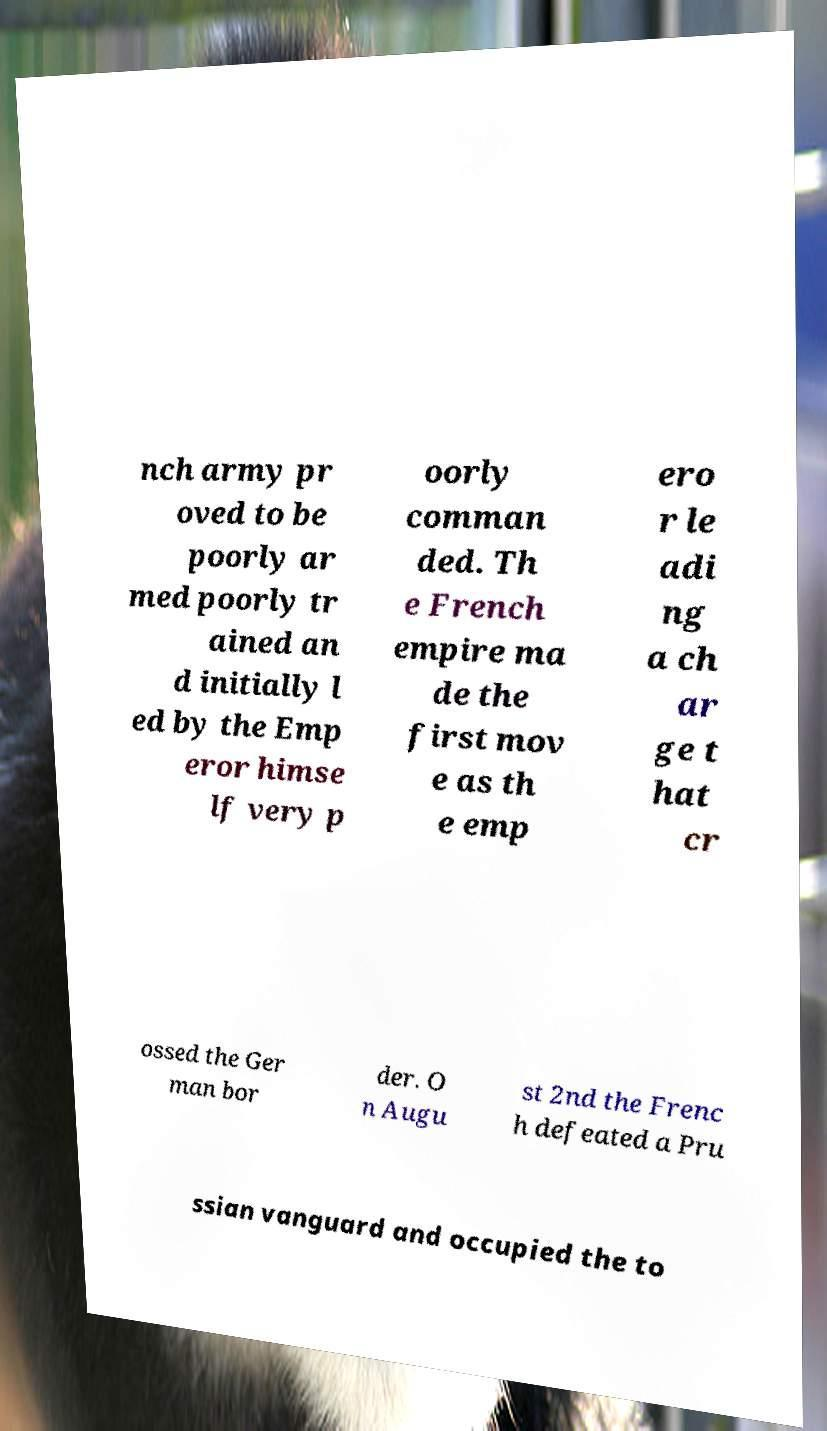I need the written content from this picture converted into text. Can you do that? nch army pr oved to be poorly ar med poorly tr ained an d initially l ed by the Emp eror himse lf very p oorly comman ded. Th e French empire ma de the first mov e as th e emp ero r le adi ng a ch ar ge t hat cr ossed the Ger man bor der. O n Augu st 2nd the Frenc h defeated a Pru ssian vanguard and occupied the to 